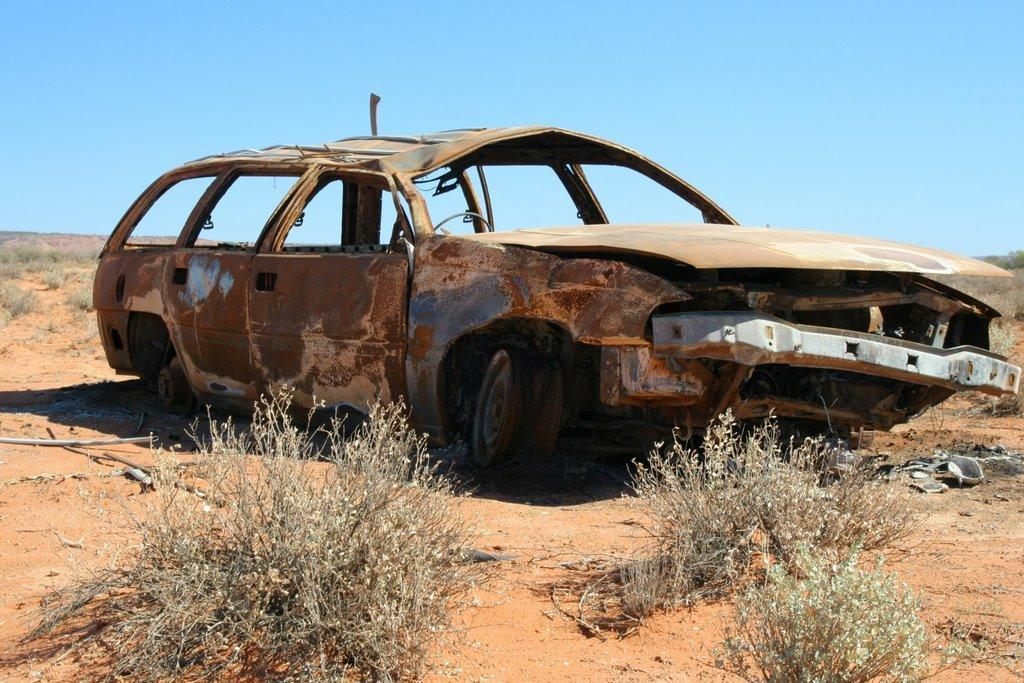What is the main subject of the image? The main subject of the image is a scrapped car. Where is the car located? The car is on a land. What can be seen around the land? There are dry plants around the land. What type of nerve can be seen connecting the car to the plants in the image? There is no nerve present in the image, and the car is not connected to the plants. 